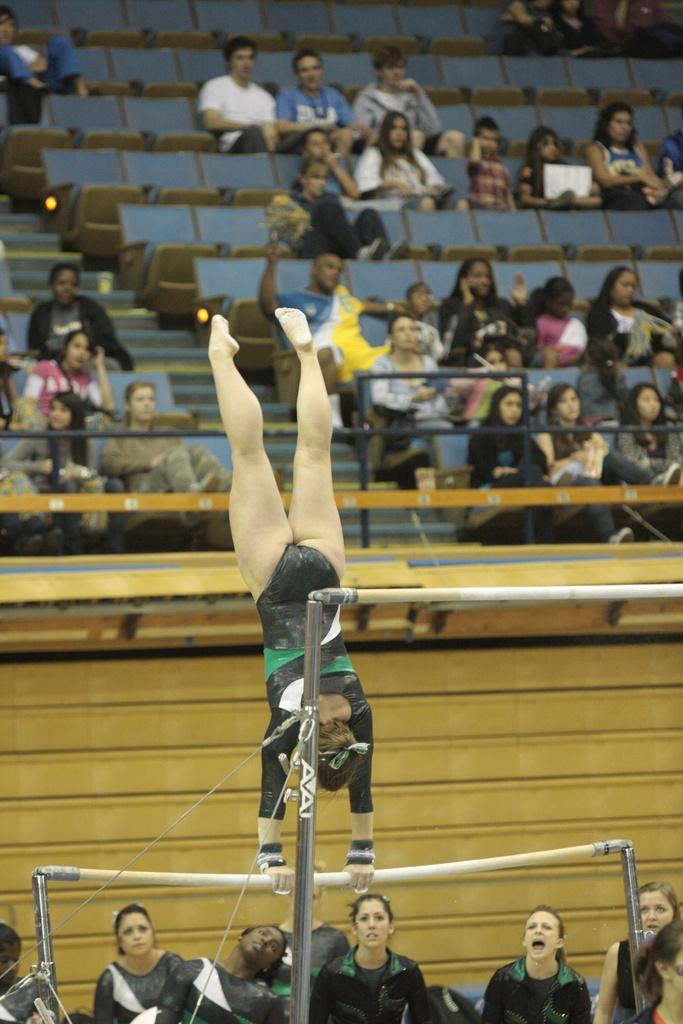<image>
Present a compact description of the photo's key features. A gymnast performing on AVAI branded uneven bars in front of a crowd 